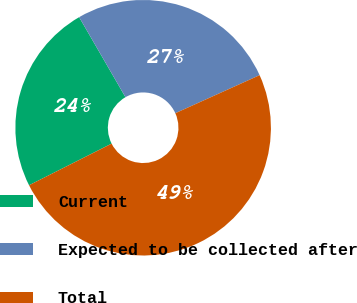Convert chart. <chart><loc_0><loc_0><loc_500><loc_500><pie_chart><fcel>Current<fcel>Expected to be collected after<fcel>Total<nl><fcel>24.08%<fcel>26.6%<fcel>49.32%<nl></chart> 